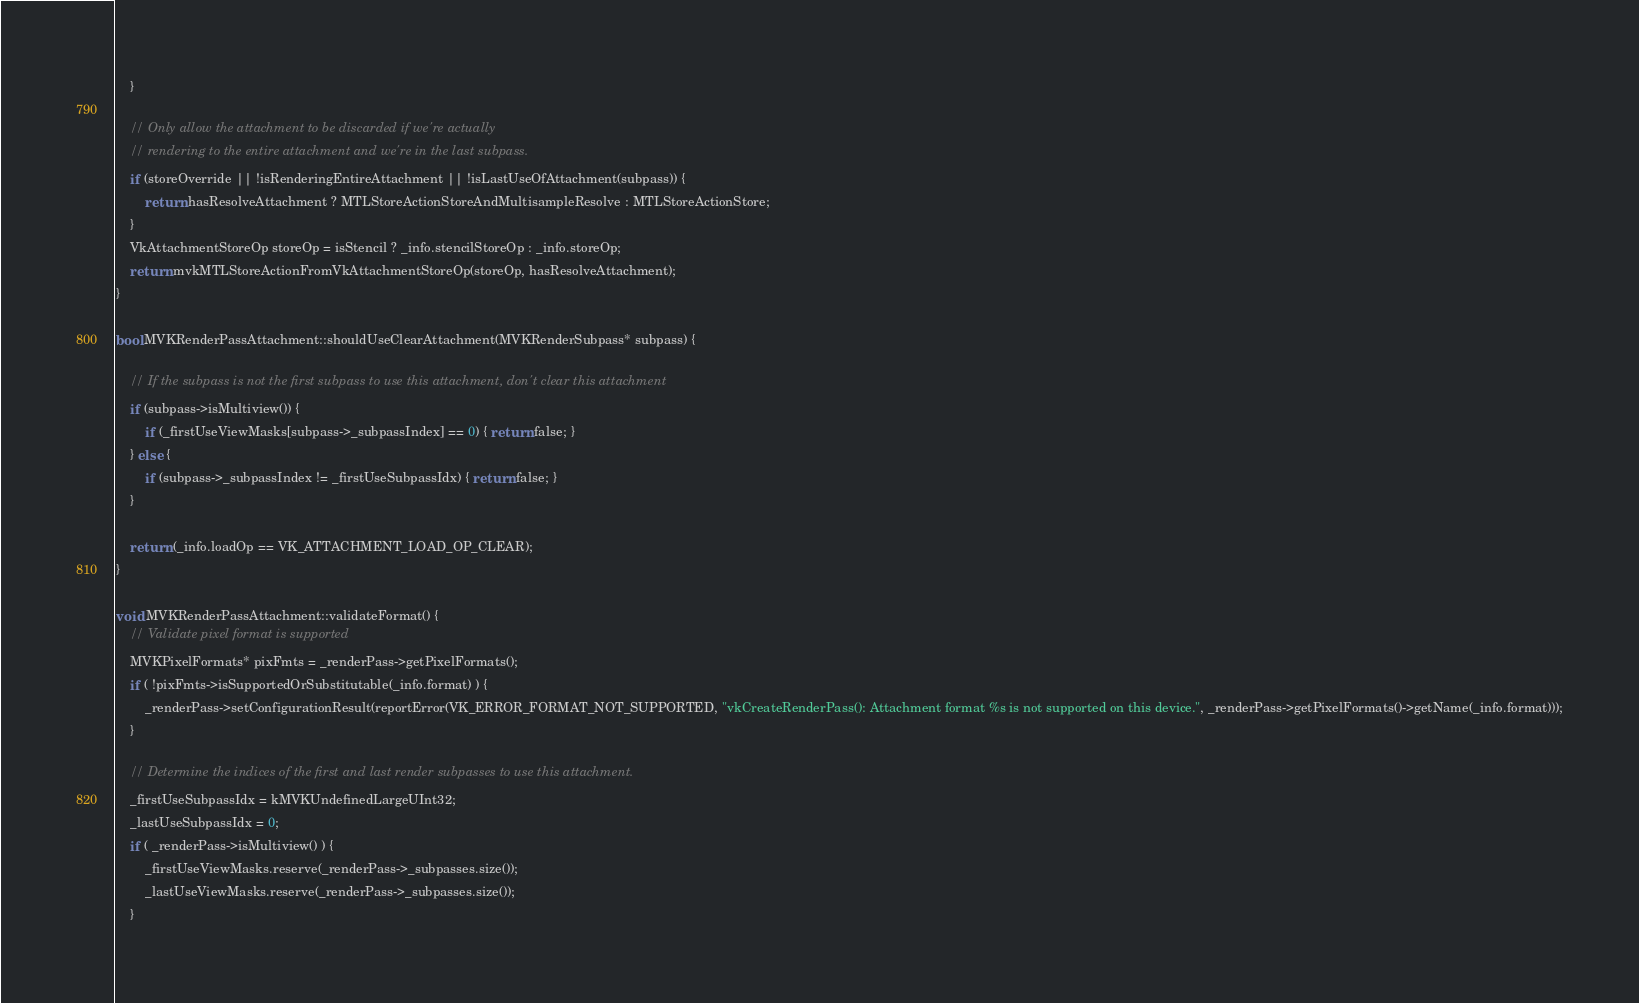Convert code to text. <code><loc_0><loc_0><loc_500><loc_500><_ObjectiveC_>	}

	// Only allow the attachment to be discarded if we're actually
	// rendering to the entire attachment and we're in the last subpass.
	if (storeOverride || !isRenderingEntireAttachment || !isLastUseOfAttachment(subpass)) {
		return hasResolveAttachment ? MTLStoreActionStoreAndMultisampleResolve : MTLStoreActionStore;
	}
	VkAttachmentStoreOp storeOp = isStencil ? _info.stencilStoreOp : _info.storeOp;
	return mvkMTLStoreActionFromVkAttachmentStoreOp(storeOp, hasResolveAttachment);
}

bool MVKRenderPassAttachment::shouldUseClearAttachment(MVKRenderSubpass* subpass) {

	// If the subpass is not the first subpass to use this attachment, don't clear this attachment
	if (subpass->isMultiview()) {
		if (_firstUseViewMasks[subpass->_subpassIndex] == 0) { return false; }
	} else {
		if (subpass->_subpassIndex != _firstUseSubpassIdx) { return false; }
	}

	return (_info.loadOp == VK_ATTACHMENT_LOAD_OP_CLEAR);
}

void MVKRenderPassAttachment::validateFormat() {
	// Validate pixel format is supported
	MVKPixelFormats* pixFmts = _renderPass->getPixelFormats();
	if ( !pixFmts->isSupportedOrSubstitutable(_info.format) ) {
		_renderPass->setConfigurationResult(reportError(VK_ERROR_FORMAT_NOT_SUPPORTED, "vkCreateRenderPass(): Attachment format %s is not supported on this device.", _renderPass->getPixelFormats()->getName(_info.format)));
	}

	// Determine the indices of the first and last render subpasses to use this attachment.
	_firstUseSubpassIdx = kMVKUndefinedLargeUInt32;
	_lastUseSubpassIdx = 0;
	if ( _renderPass->isMultiview() ) {
		_firstUseViewMasks.reserve(_renderPass->_subpasses.size());
		_lastUseViewMasks.reserve(_renderPass->_subpasses.size());
	}</code> 